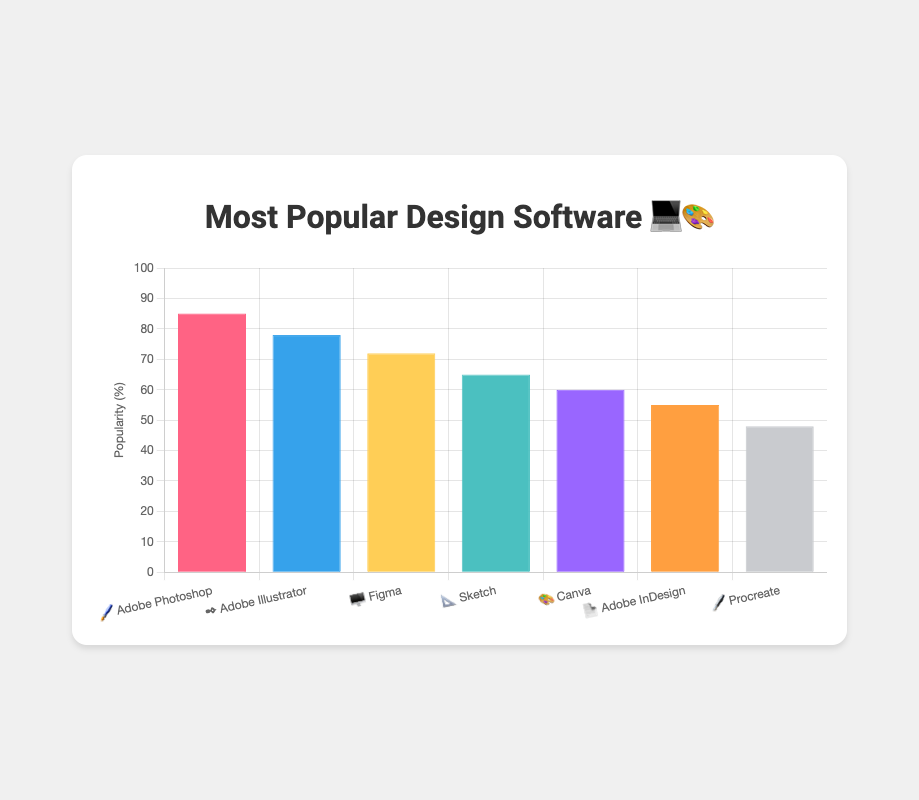what's the title of the chart? The title is given at the top of the chart, indicating the overall topic of the data presented.
Answer: Most Popular Design Software 💻🎨 how many design software options are shown in the chart? Each bar in the chart represents a design software option, and there are seven bars in total.
Answer: 7 which design software has the highest popularity? The highest bar in the chart represents the software with the highest popularity percentage.
Answer: Adobe Photoshop how does the popularity of Sketch compare to that of Canva? The bar representing Sketch has a popularity of 65%, while the bar for Canva shows 60%, meaning Sketch has a 5% higher popularity.
Answer: Sketch is 5% more popular than Canva what's the total popularity percentage of all Adobe software shown? Summing up the popularity percentages of Adobe Photoshop (85%), Adobe Illustrator (78%), and Adobe InDesign (55%) gives the total.
Answer: 218% Which software has the least popularity among the shown options? The smallest bar in the chart represents the software with the least popularity percentage.
Answer: Procreate what is the average popularity of the first three design software options listed? Adding up the popularity percentages of the first three software (85% for Adobe Photoshop, 78% for Adobe Illustrator, and 72% for Figma) and then dividing by 3.
Answer: 78.33% What is the popularity difference between Adobe Illustrator (✒️) and Procreate (🖋️)? Subtract the popularity percentage of Procreate (48%) from Adobe Illustrator's percentage (78%).
Answer: 30% What is the combined popularity of Figma (🖥️) and Sketch (📐)? Adding the popularity percentages of Figma (72%) and Sketch (65%).
Answer: 137% Which design software(s) have popularity percentages above 70%? The bars that extend above the 70% mark belong to Adobe Photoshop (85%), Adobe Illustrator (78%), and Figma (72%).
Answer: Adobe Photoshop, Adobe Illustrator, and Figma 